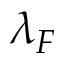<formula> <loc_0><loc_0><loc_500><loc_500>\lambda _ { F }</formula> 